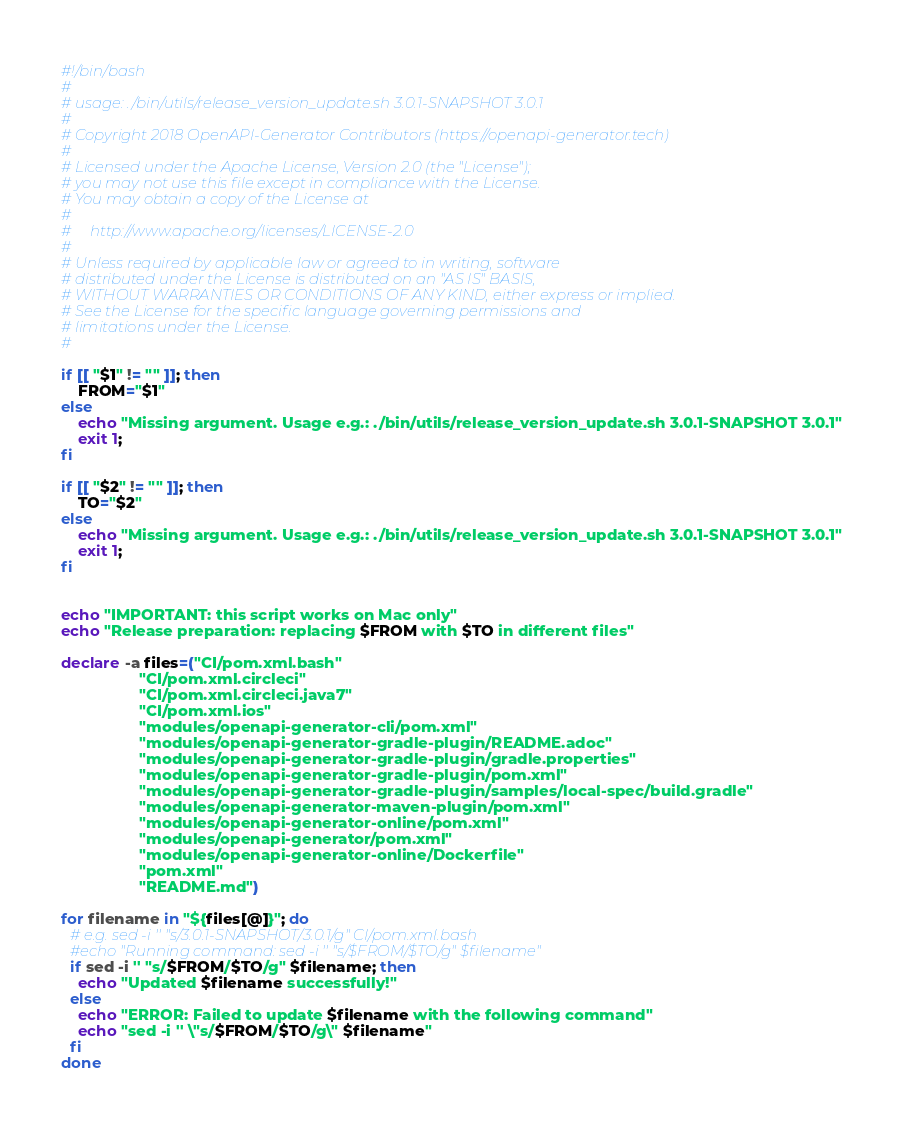Convert code to text. <code><loc_0><loc_0><loc_500><loc_500><_Bash_>#!/bin/bash
#
# usage: ./bin/utils/release_version_update.sh 3.0.1-SNAPSHOT 3.0.1
#
# Copyright 2018 OpenAPI-Generator Contributors (https://openapi-generator.tech)
#
# Licensed under the Apache License, Version 2.0 (the "License");
# you may not use this file except in compliance with the License.
# You may obtain a copy of the License at
#
#     http://www.apache.org/licenses/LICENSE-2.0
#
# Unless required by applicable law or agreed to in writing, software
# distributed under the License is distributed on an "AS IS" BASIS,
# WITHOUT WARRANTIES OR CONDITIONS OF ANY KIND, either express or implied.
# See the License for the specific language governing permissions and
# limitations under the License.
#

if [[ "$1" != "" ]]; then
    FROM="$1"
else
    echo "Missing argument. Usage e.g.: ./bin/utils/release_version_update.sh 3.0.1-SNAPSHOT 3.0.1"
    exit 1;
fi

if [[ "$2" != "" ]]; then
    TO="$2"
else
    echo "Missing argument. Usage e.g.: ./bin/utils/release_version_update.sh 3.0.1-SNAPSHOT 3.0.1"
    exit 1;
fi


echo "IMPORTANT: this script works on Mac only"
echo "Release preparation: replacing $FROM with $TO in different files"

declare -a files=("CI/pom.xml.bash"
                  "CI/pom.xml.circleci"
                  "CI/pom.xml.circleci.java7"
                  "CI/pom.xml.ios"
                  "modules/openapi-generator-cli/pom.xml"
                  "modules/openapi-generator-gradle-plugin/README.adoc"
                  "modules/openapi-generator-gradle-plugin/gradle.properties"
                  "modules/openapi-generator-gradle-plugin/pom.xml"
                  "modules/openapi-generator-gradle-plugin/samples/local-spec/build.gradle"
                  "modules/openapi-generator-maven-plugin/pom.xml"
                  "modules/openapi-generator-online/pom.xml"
                  "modules/openapi-generator/pom.xml"
                  "modules/openapi-generator-online/Dockerfile"
                  "pom.xml"
                  "README.md")

for filename in "${files[@]}"; do
  # e.g. sed -i '' "s/3.0.1-SNAPSHOT/3.0.1/g" CI/pom.xml.bash
  #echo "Running command: sed -i '' "s/$FROM/$TO/g" $filename"
  if sed -i '' "s/$FROM/$TO/g" $filename; then
    echo "Updated $filename successfully!"
  else
    echo "ERROR: Failed to update $filename with the following command"
    echo "sed -i '' \"s/$FROM/$TO/g\" $filename"
  fi
done
</code> 